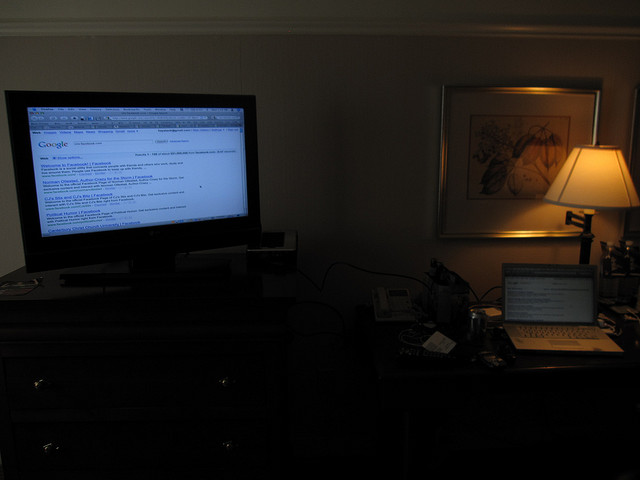<image>What hand would the person operating this computer use to operate the mouse? It is ambiguous which hand the person would use to operate the mouse. It could be either the right or left hand. What is sitting in front of the TV? It is ambiguous what is sitting in front of the TV. It could be a computer, dresser, chair or laptop. What hand would the person operating this computer use to operate the mouse? It depends on the person. Some people may use their left hand to operate the mouse, while others may use their right hand. What is sitting in front of the TV? I am not sure what is sitting in front of the TV. It could be a computer, dresser, chair, or something else. 